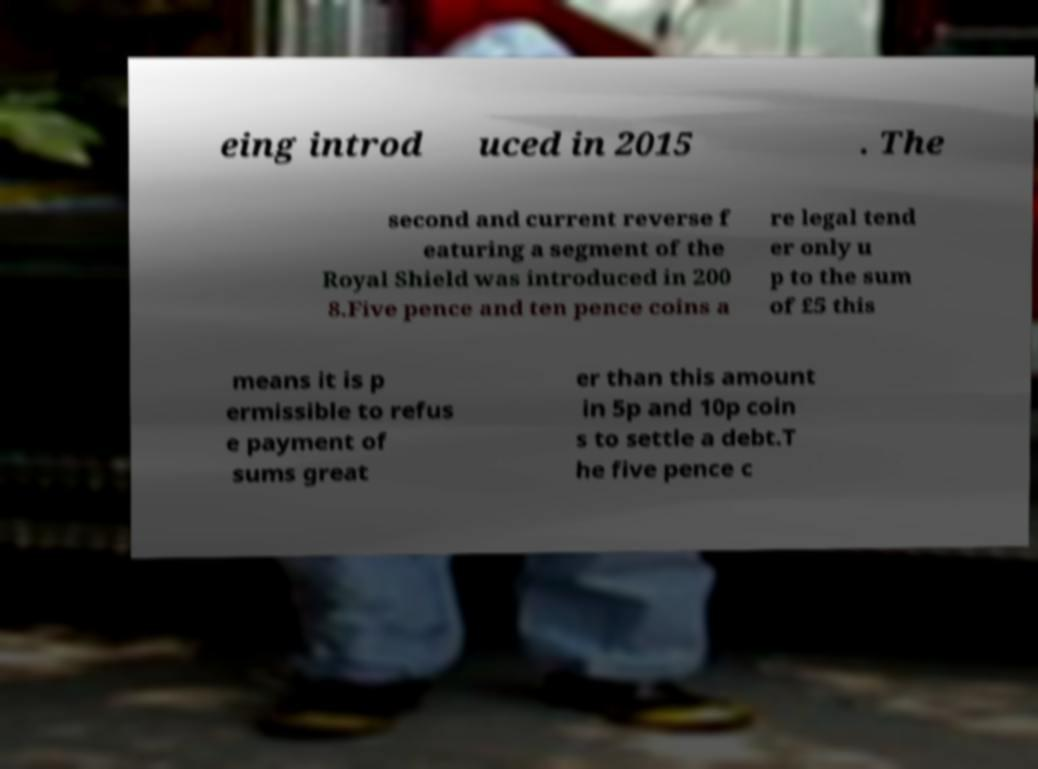I need the written content from this picture converted into text. Can you do that? eing introd uced in 2015 . The second and current reverse f eaturing a segment of the Royal Shield was introduced in 200 8.Five pence and ten pence coins a re legal tend er only u p to the sum of £5 this means it is p ermissible to refus e payment of sums great er than this amount in 5p and 10p coin s to settle a debt.T he five pence c 